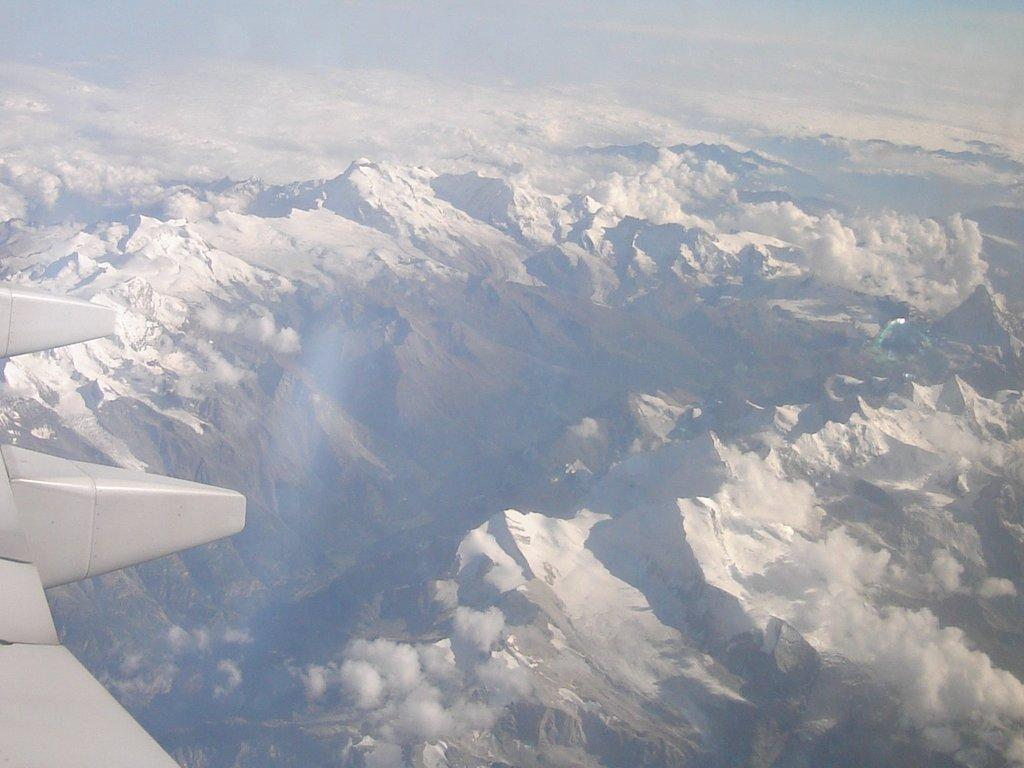What type of view is provided in the image? The image provides an aerial view. What can be seen from this aerial view? The aerial view is of mountains. How many tigers can be seen in the image? There are no tigers present in the image, as it features an aerial view of mountains. What unit of measurement is used to determine the height of the mountains in the image? The image does not provide specific measurements or units of measurement for the mountains. 